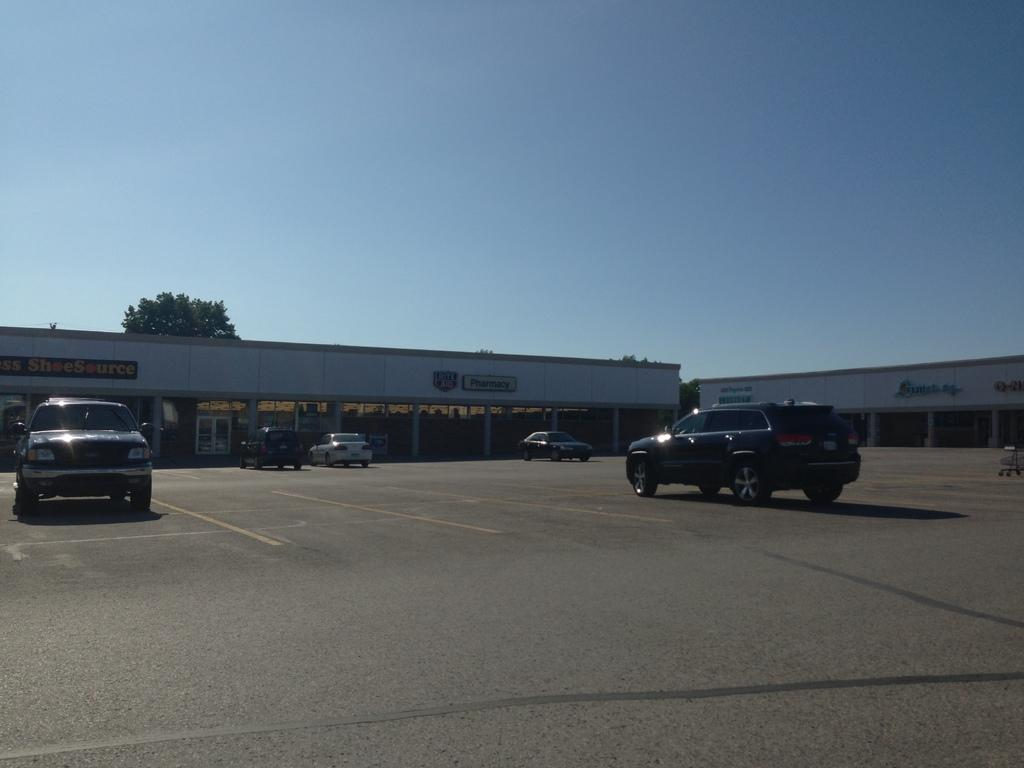What is present on the path in the image? There are vehicles on the path in the image. What structures can be seen in the image? There are buildings visible in the image. What type of vegetation is present in the image? There are trees in the image. What can be seen in the background of the image? The sky is visible in the background of the image. Can you tell me where the coast is located in the image? There is no coast present in the image; it features vehicles on a path, buildings, trees, and the sky. What type of trail is visible in the image? There is no trail mentioned in the image; it features vehicles on a path, buildings, trees, and the sky. 